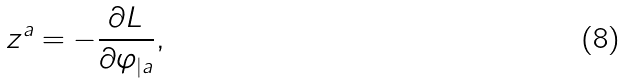Convert formula to latex. <formula><loc_0><loc_0><loc_500><loc_500>z ^ { a } = - \frac { \partial L } { \partial \varphi _ { | a } } ,</formula> 